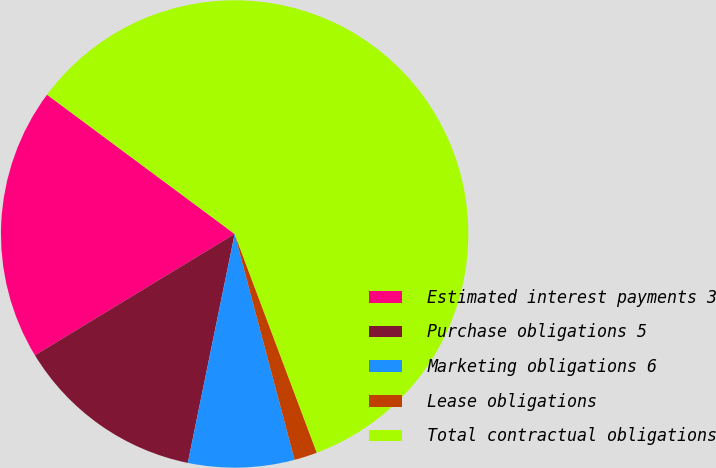Convert chart to OTSL. <chart><loc_0><loc_0><loc_500><loc_500><pie_chart><fcel>Estimated interest payments 3<fcel>Purchase obligations 5<fcel>Marketing obligations 6<fcel>Lease obligations<fcel>Total contractual obligations<nl><fcel>18.85%<fcel>13.1%<fcel>7.34%<fcel>1.59%<fcel>59.12%<nl></chart> 